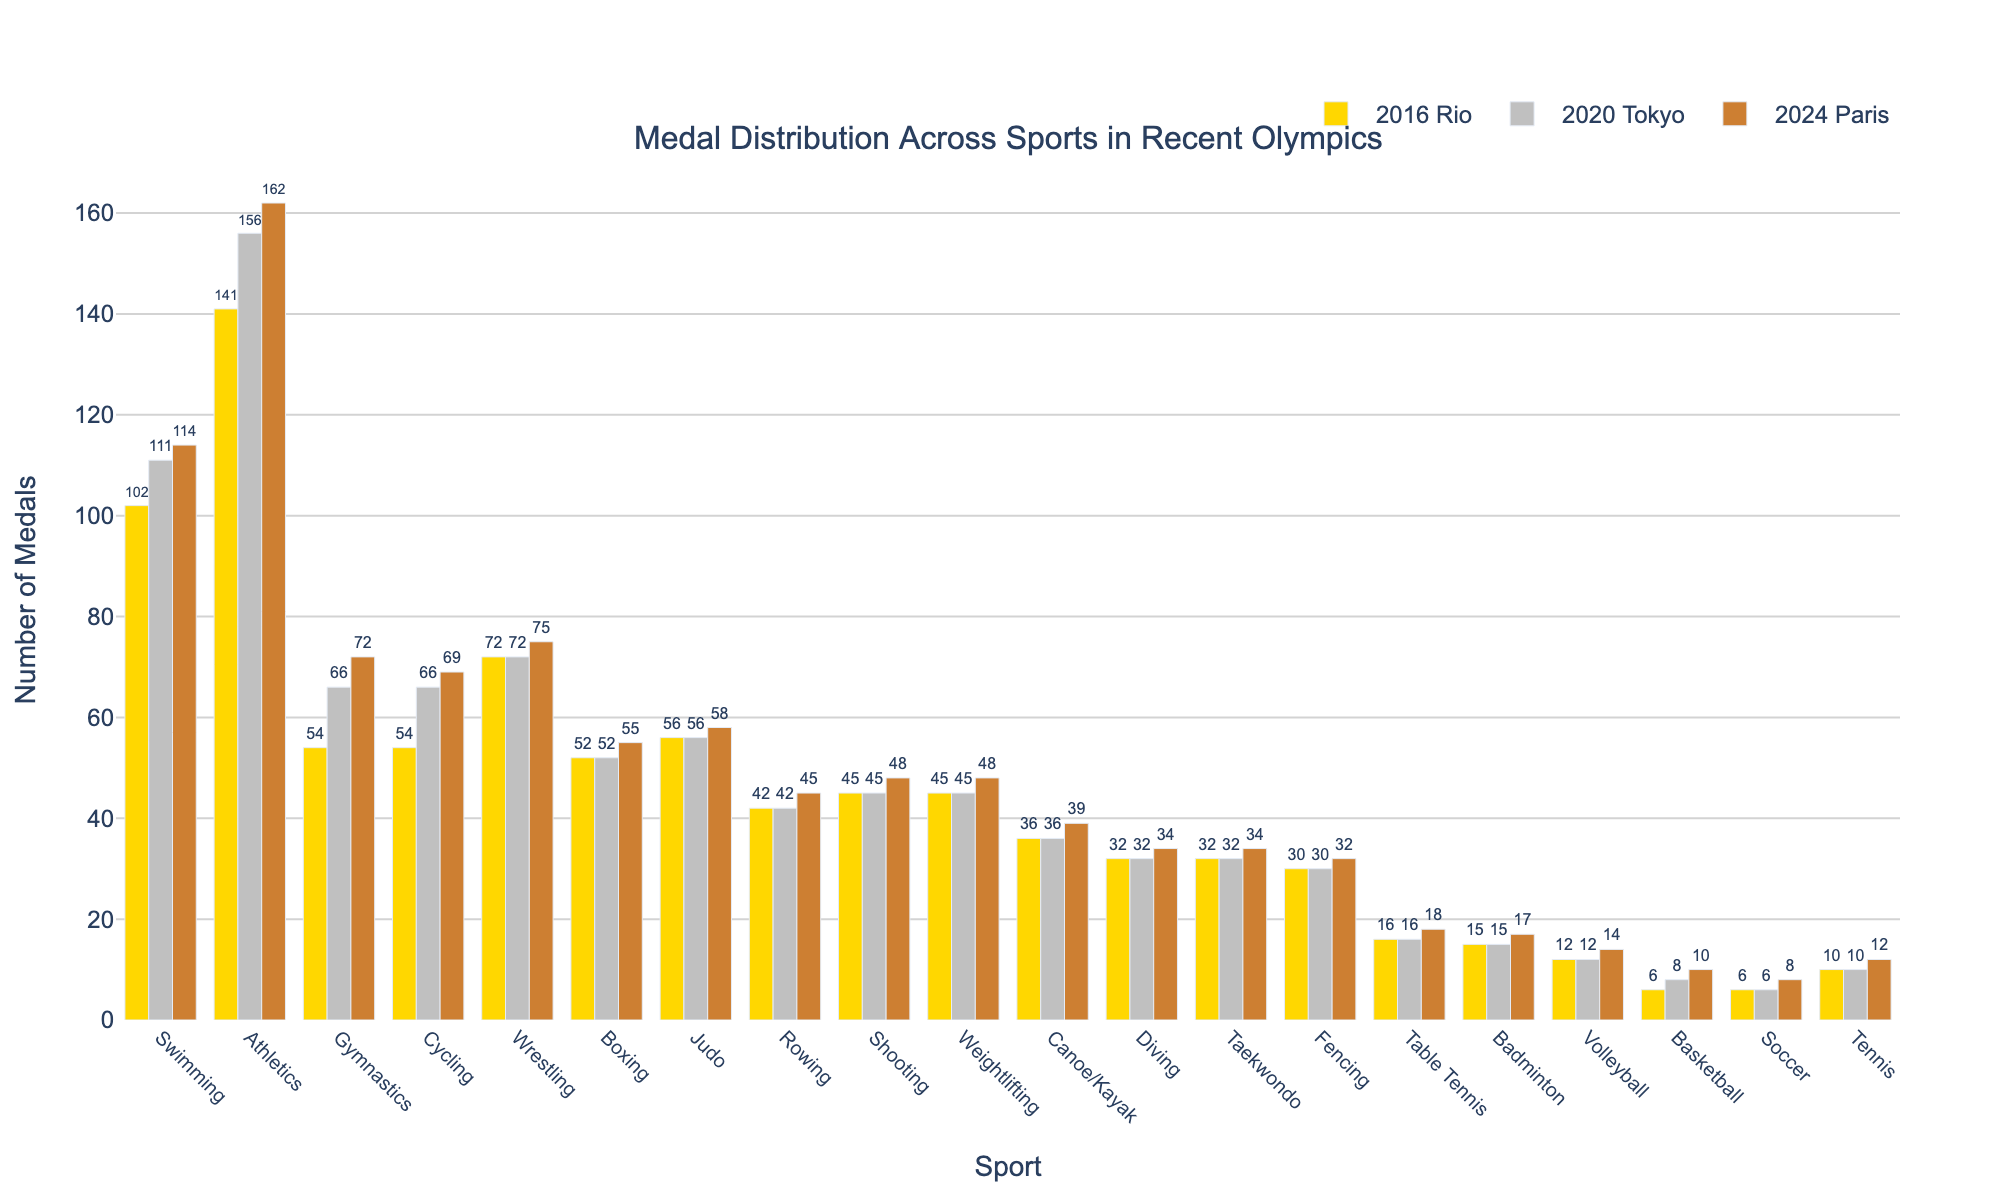Which sport had the highest number of medals in the 2024 Paris Olympics? By looking at the bar heights under the 2024 Paris section, Athletics has the tallest bar, indicating it had the highest number of medals.
Answer: Athletics How many more medals were won in Swimming in the 2020 Tokyo Olympics compared to 2016 Rio? Observe the bar heights for Swimming in both the 2016 Rio and 2020 Tokyo segments. The difference is 111 - 102 = 9 medals.
Answer: 9 Which three sports saw an increase in the number of medals in each of the three Olympic Games? By inspecting the bars for each sport across all three years, Athletics, Gymnastics, and Swimming have consistently increasing bars over the years.
Answer: Athletics, Gymnastics, Swimming What is the total number of medals won in Boxing across all three Olympic Games? Summing the bars for Boxing in 2016, 2020, and 2024 gives 52 + 52 + 55 = 159 medals.
Answer: 159 Which sports had an equal number of medals in the 2016 Rio and 2020 Tokyo Olympics? By comparing the bar heights for each sport between 2016 and 2020, Wrestling (72), Boxing (52), Judo (56), Rowing (42), Shooting (45), Weightlifting (45), Canoe/Kayak (36), Diving (32), Taekwondo (32), Fencing (30), Table Tennis (16), and Badminton (15) had equal numbers of medals.
Answer: Wrestling, Boxing, Judo, Rowing, Shooting, Weightlifting, Canoe/Kayak, Diving, Taekwondo, Fencing, Table Tennis, Badminton What is the average number of medals won per sport in the 2024 Paris Olympics? Summing all the bars for 2024 Paris gives 1152 medals, and since there are 20 sports, the average is 1152 / 20 = 57.6 medals.
Answer: 57.6 Did the number of medals in Volleyball increase, decrease, or stay the same over the three Olympic Games? By looking at the bar heights for Volleyball in 2016, 2020, and 2024, the bars increase: 12, 12, and 14, showing an increase.
Answer: Increase For which sport did the number of medals remain constant across all three Olympic Games? By comparing the bar heights for all three years, Rowing (42) and Shooting (45) remained constant.
Answer: Rowing, Shooting 